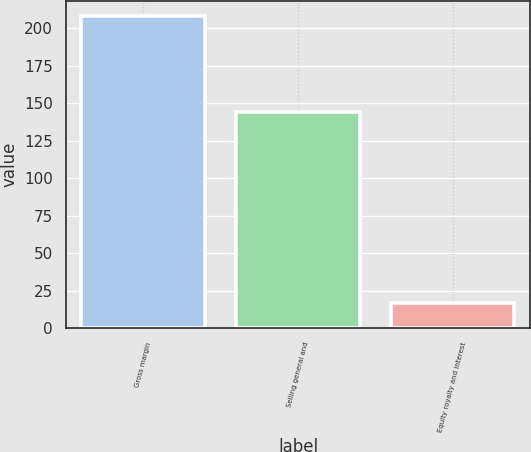Convert chart to OTSL. <chart><loc_0><loc_0><loc_500><loc_500><bar_chart><fcel>Gross margin<fcel>Selling general and<fcel>Equity royalty and interest<nl><fcel>208<fcel>144<fcel>17<nl></chart> 